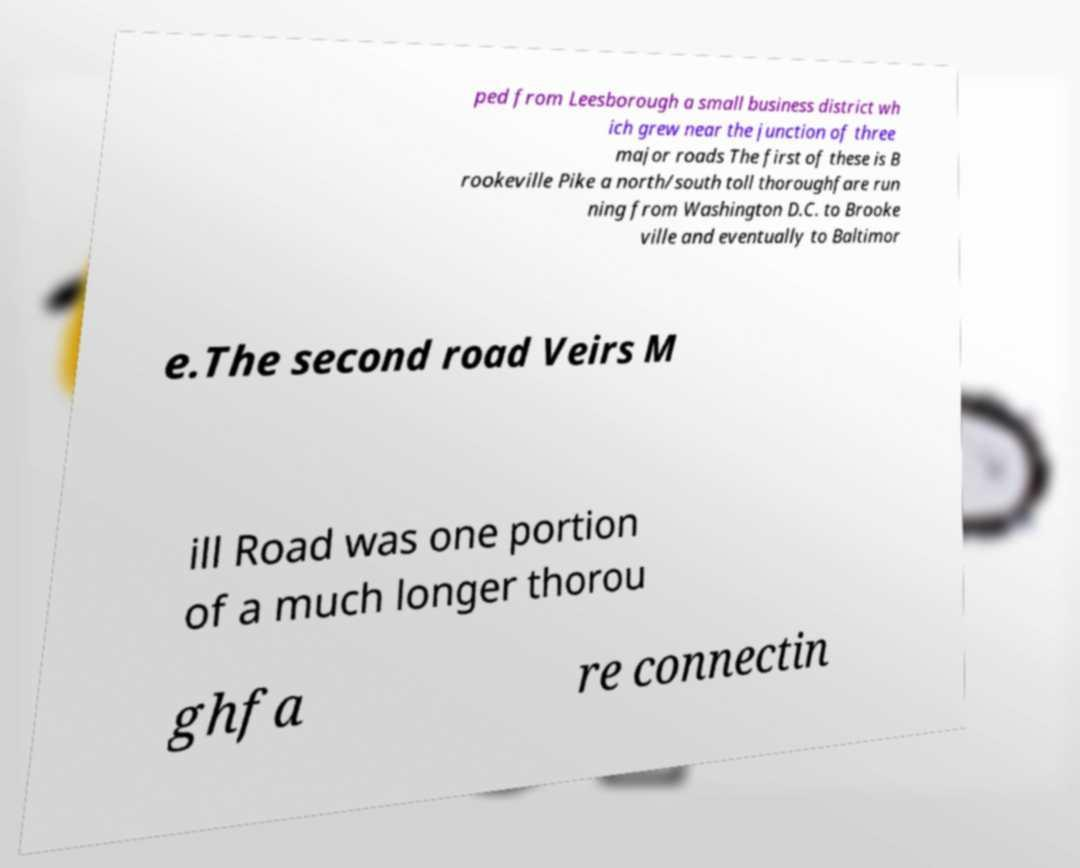What messages or text are displayed in this image? I need them in a readable, typed format. ped from Leesborough a small business district wh ich grew near the junction of three major roads The first of these is B rookeville Pike a north/south toll thoroughfare run ning from Washington D.C. to Brooke ville and eventually to Baltimor e.The second road Veirs M ill Road was one portion of a much longer thorou ghfa re connectin 